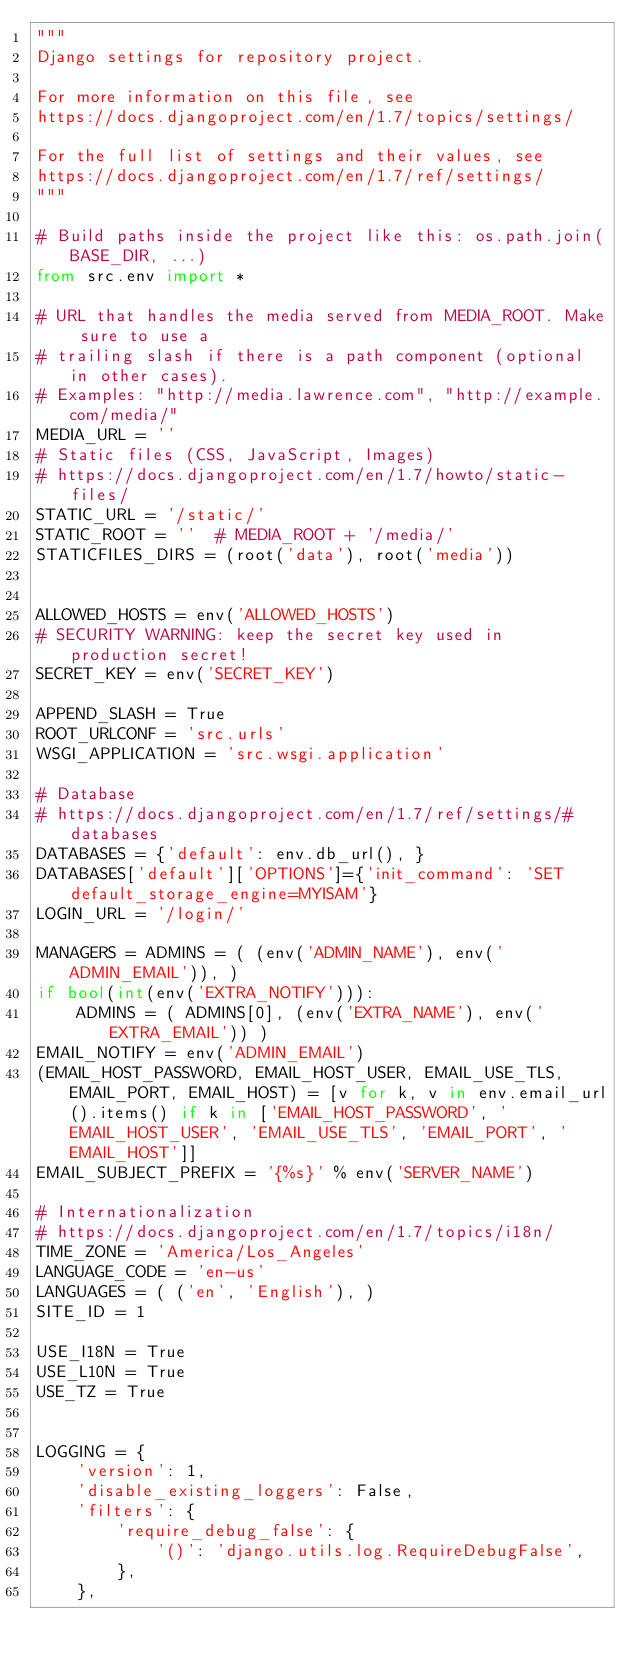Convert code to text. <code><loc_0><loc_0><loc_500><loc_500><_Python_>"""
Django settings for repository project.

For more information on this file, see
https://docs.djangoproject.com/en/1.7/topics/settings/

For the full list of settings and their values, see
https://docs.djangoproject.com/en/1.7/ref/settings/
"""

# Build paths inside the project like this: os.path.join(BASE_DIR, ...)
from src.env import *

# URL that handles the media served from MEDIA_ROOT. Make sure to use a
# trailing slash if there is a path component (optional in other cases).
# Examples: "http://media.lawrence.com", "http://example.com/media/"
MEDIA_URL = ''
# Static files (CSS, JavaScript, Images)
# https://docs.djangoproject.com/en/1.7/howto/static-files/
STATIC_URL = '/static/'
STATIC_ROOT = ''  # MEDIA_ROOT + '/media/'
STATICFILES_DIRS = (root('data'), root('media'))


ALLOWED_HOSTS = env('ALLOWED_HOSTS')
# SECURITY WARNING: keep the secret key used in production secret!
SECRET_KEY = env('SECRET_KEY')

APPEND_SLASH = True
ROOT_URLCONF = 'src.urls'
WSGI_APPLICATION = 'src.wsgi.application'

# Database
# https://docs.djangoproject.com/en/1.7/ref/settings/#databases
DATABASES = {'default': env.db_url(), }
DATABASES['default']['OPTIONS']={'init_command': 'SET default_storage_engine=MYISAM'}
LOGIN_URL = '/login/'

MANAGERS = ADMINS = ( (env('ADMIN_NAME'), env('ADMIN_EMAIL')), )
if bool(int(env('EXTRA_NOTIFY'))):
    ADMINS = ( ADMINS[0], (env('EXTRA_NAME'), env('EXTRA_EMAIL')) )
EMAIL_NOTIFY = env('ADMIN_EMAIL')
(EMAIL_HOST_PASSWORD, EMAIL_HOST_USER, EMAIL_USE_TLS, EMAIL_PORT, EMAIL_HOST) = [v for k, v in env.email_url().items() if k in ['EMAIL_HOST_PASSWORD', 'EMAIL_HOST_USER', 'EMAIL_USE_TLS', 'EMAIL_PORT', 'EMAIL_HOST']]
EMAIL_SUBJECT_PREFIX = '{%s}' % env('SERVER_NAME')

# Internationalization
# https://docs.djangoproject.com/en/1.7/topics/i18n/
TIME_ZONE = 'America/Los_Angeles'
LANGUAGE_CODE = 'en-us'
LANGUAGES = ( ('en', 'English'), )
SITE_ID = 1

USE_I18N = True
USE_L10N = True
USE_TZ = True


LOGGING = {
    'version': 1,
    'disable_existing_loggers': False,
    'filters': {
        'require_debug_false': {
            '()': 'django.utils.log.RequireDebugFalse',
        },
    },</code> 